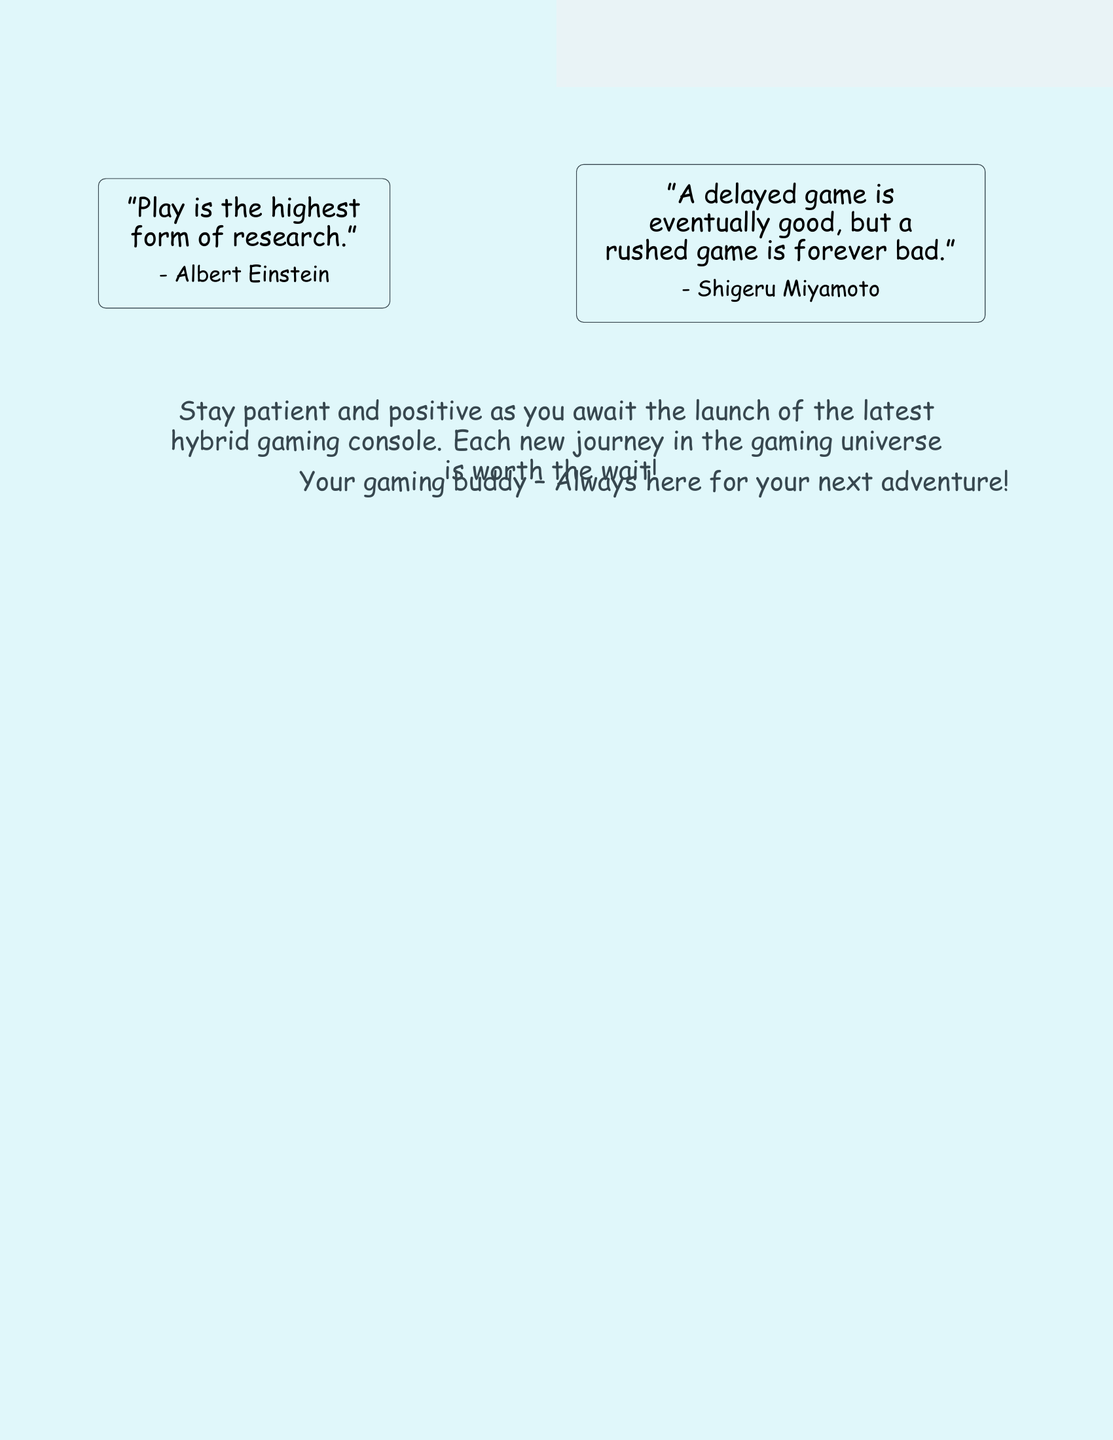What is the main title of the card? The main title is prominently displayed at the top of the card, emphasizing its theme.
Answer: Keep Calm and Game On Who is quoted on the card regarding play as research? This information can be found within one of the motivational quotes on the card.
Answer: Albert Einstein What color is the background of the card? The background color is described in the document and is an important design feature.
Answer: E0F7FA What does the card encourage recipients to do as they await a gaming console? This encouragement is part of a motivational message included in the design.
Answer: Stay patient and positive Who is the card from? The closing message identifies the sender and offers a sense of companionship.
Answer: Your gaming buddy How many motivational quotes are included in the card? This is a straightforward count of the distinct quotes present in the document.
Answer: Two 